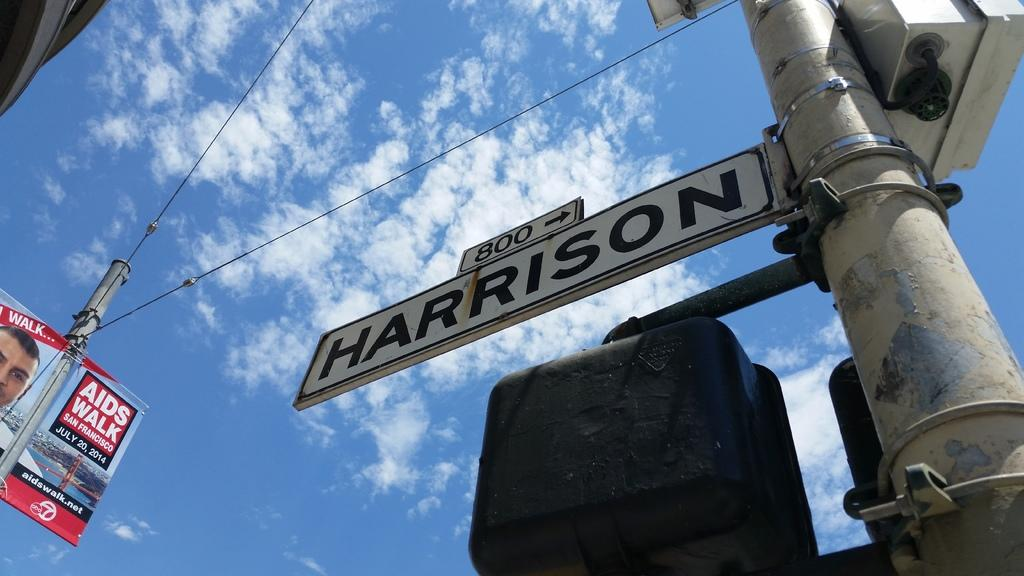<image>
Share a concise interpretation of the image provided. Looking up at the street sign for Harrison reveals a blue sky. 